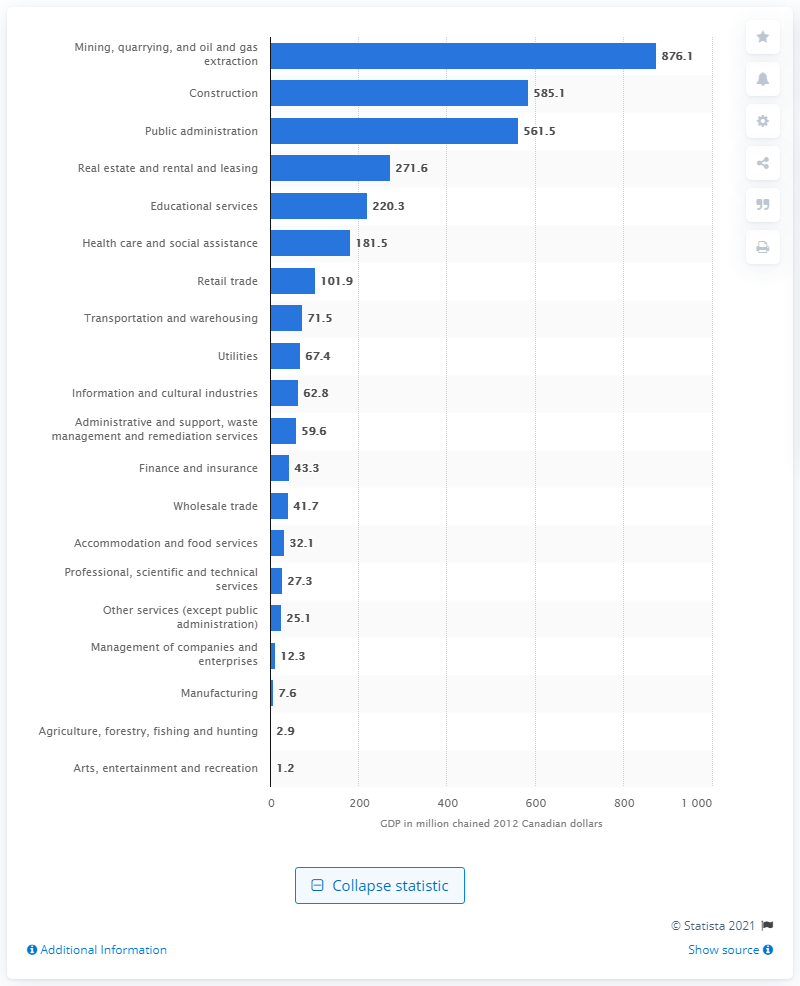Give some essential details in this illustration. In 2012, the Gross Domestic Product (GDP) of the construction industry in Nunavut was 585.1 million Canadian dollars. 